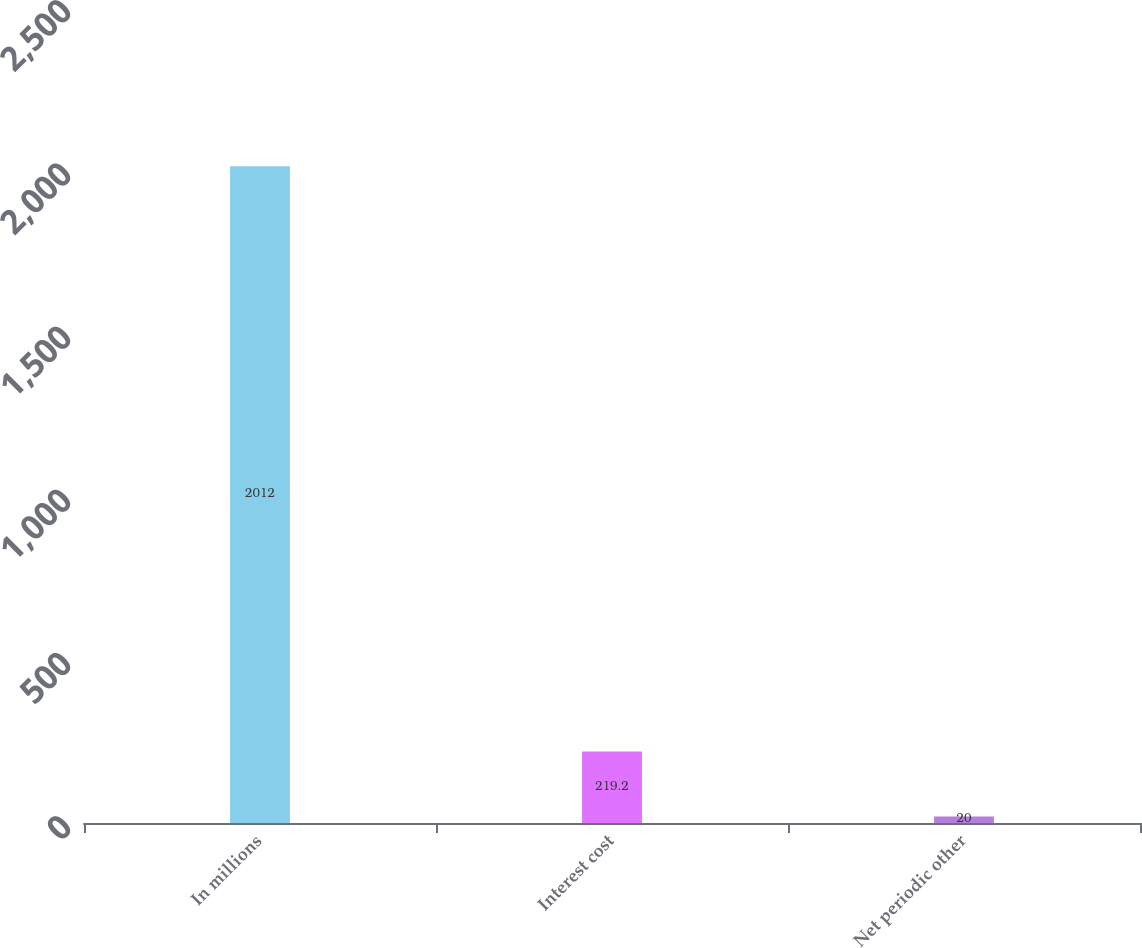<chart> <loc_0><loc_0><loc_500><loc_500><bar_chart><fcel>In millions<fcel>Interest cost<fcel>Net periodic other<nl><fcel>2012<fcel>219.2<fcel>20<nl></chart> 